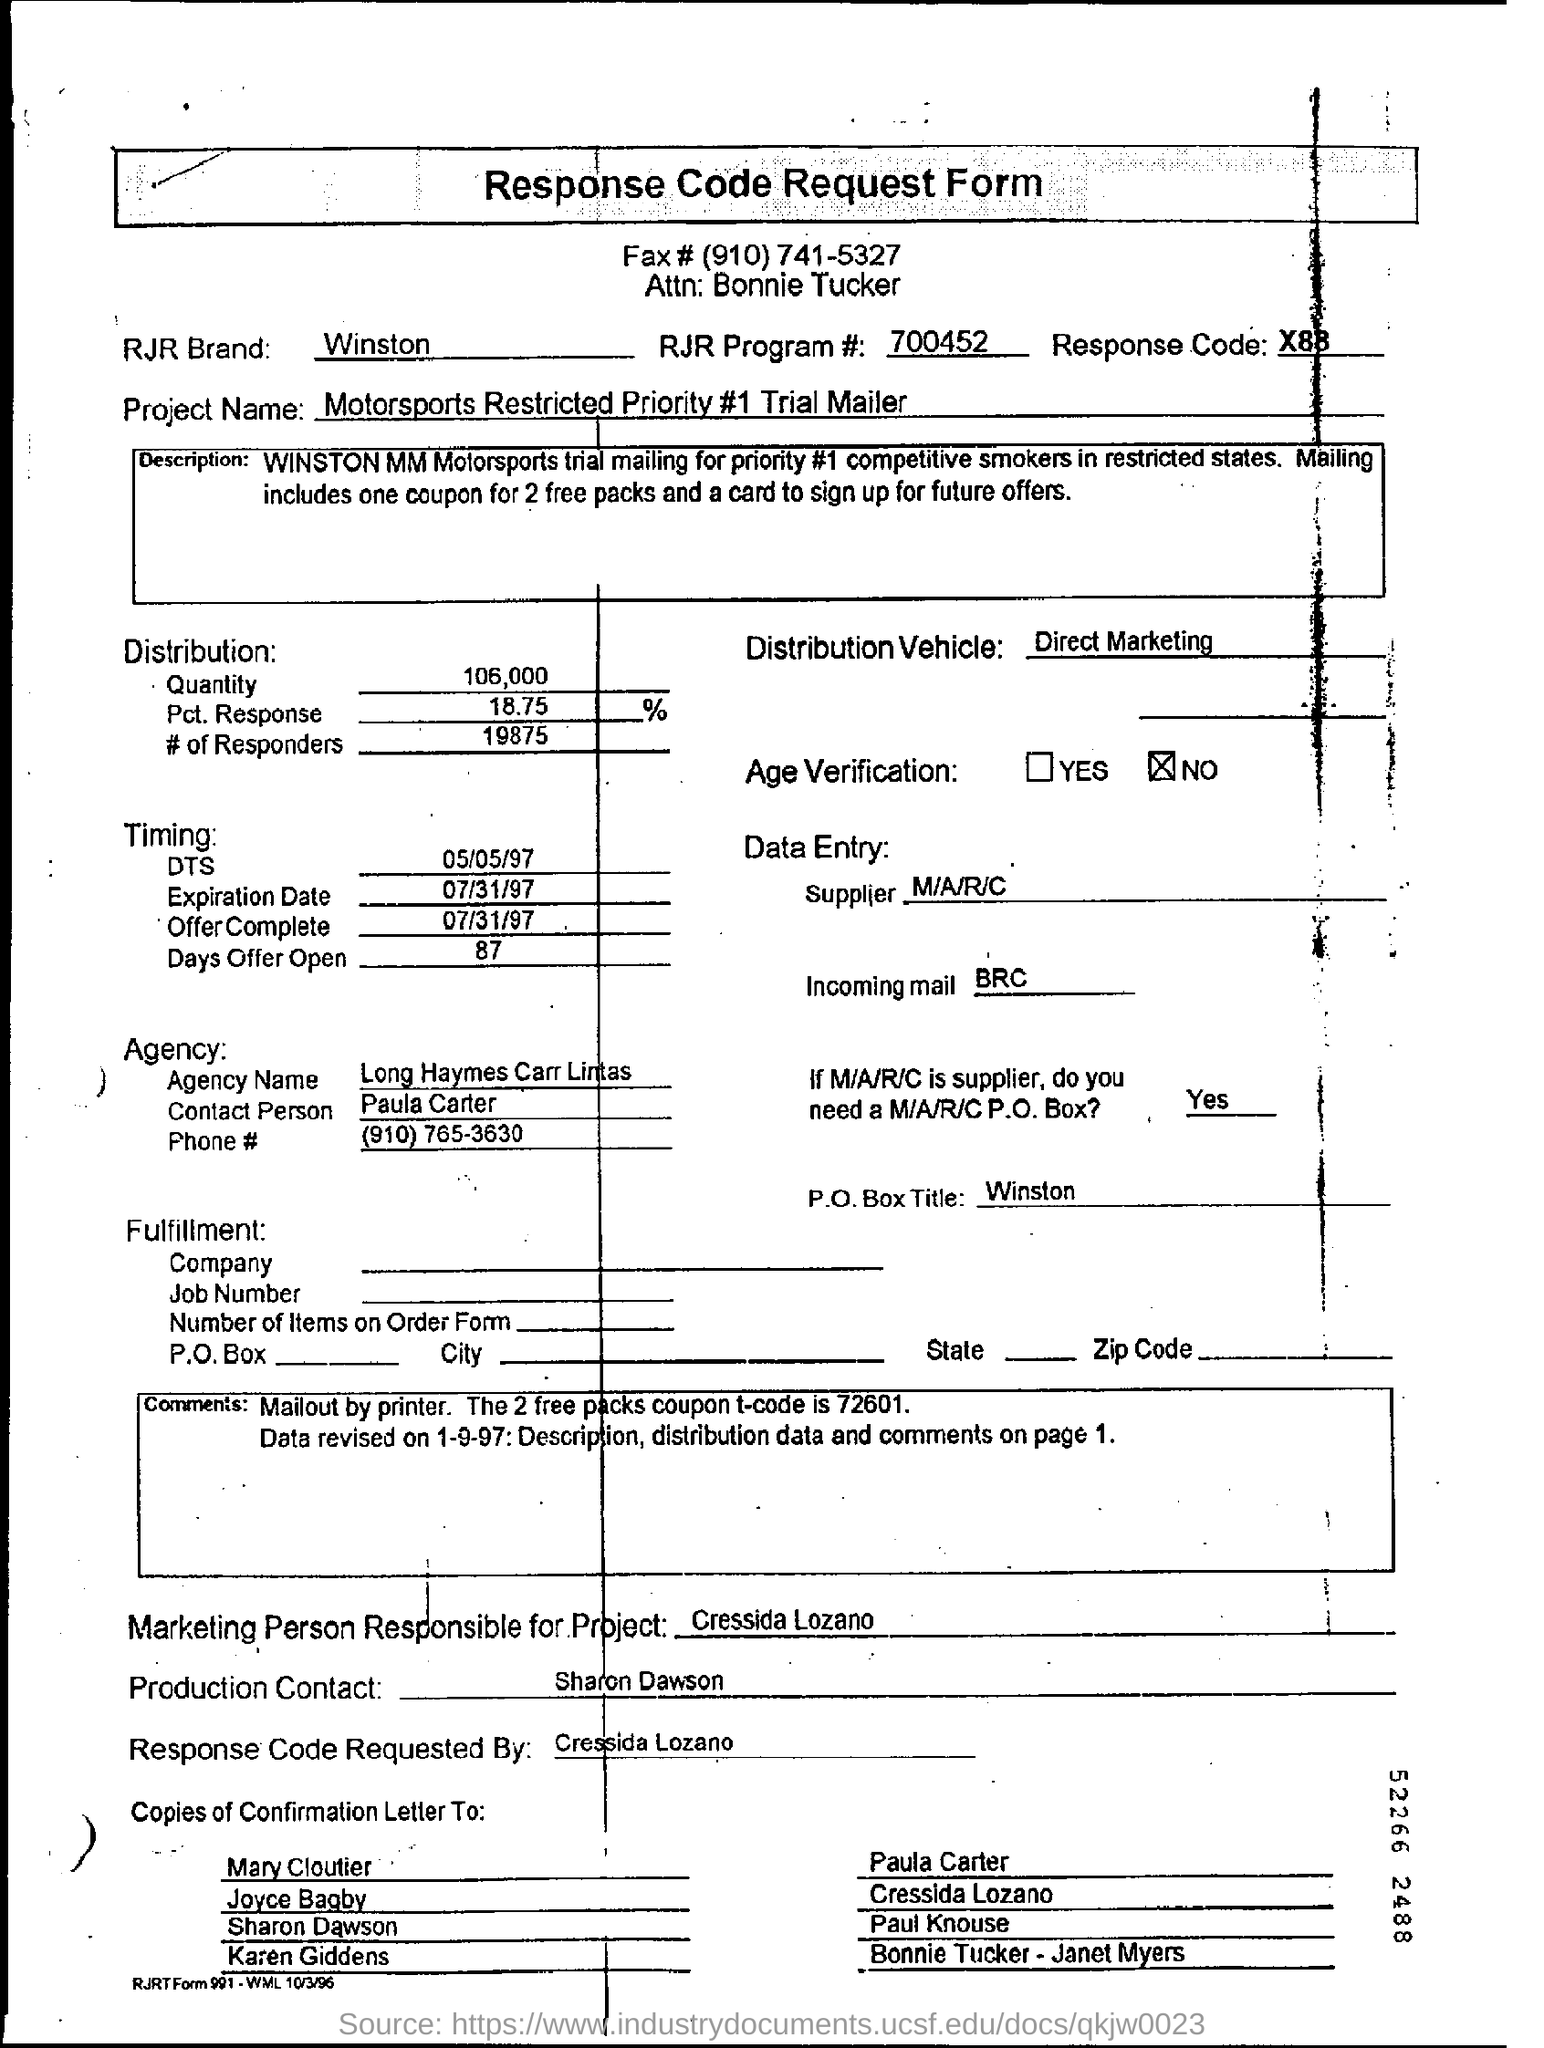Give some essential details in this illustration. The heading of the document is 'Response Code Request Form'. The RJR Brand is associated with the company R.J. Reynolds, and it primarily marketed Winston cigarettes. 